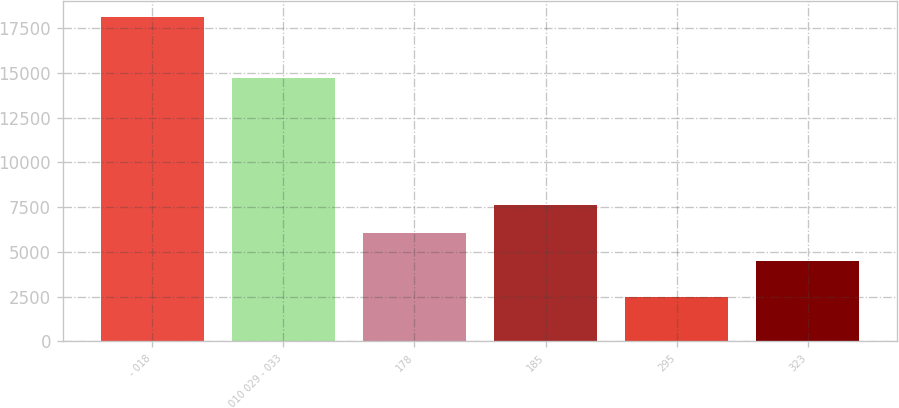Convert chart. <chart><loc_0><loc_0><loc_500><loc_500><bar_chart><fcel>- 018<fcel>010 029 - 033<fcel>178<fcel>185<fcel>295<fcel>323<nl><fcel>18096<fcel>14701<fcel>6059<fcel>7618<fcel>2506<fcel>4500<nl></chart> 